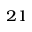<formula> <loc_0><loc_0><loc_500><loc_500>^ { 2 1 }</formula> 